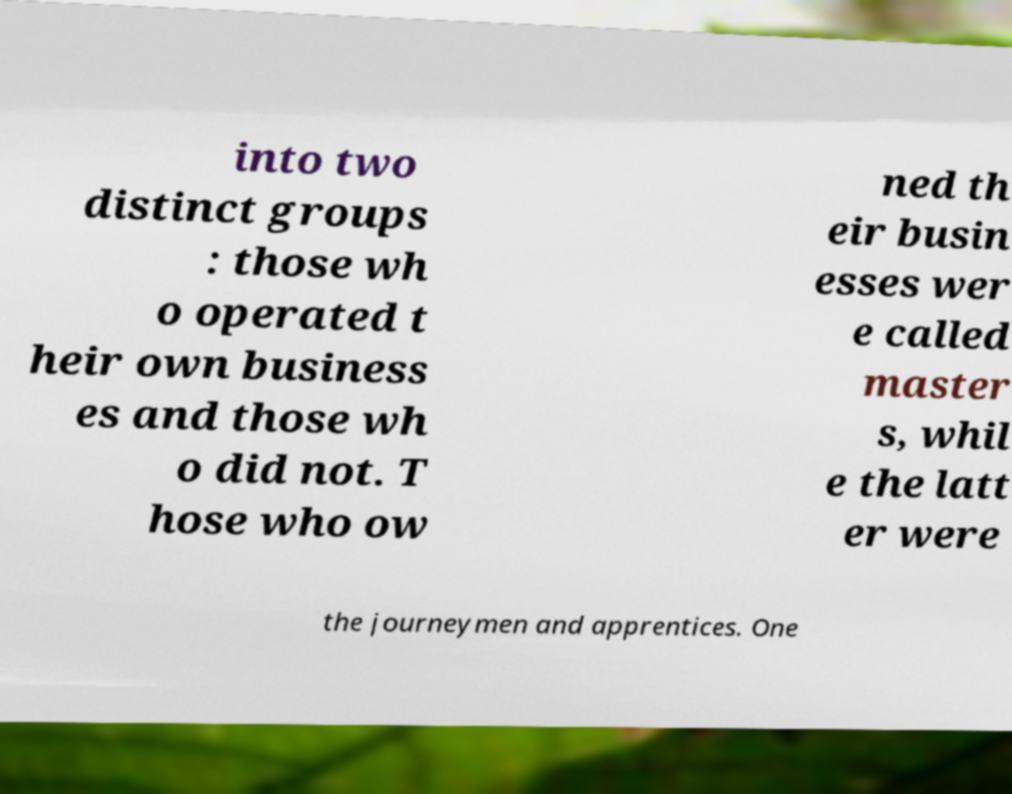For documentation purposes, I need the text within this image transcribed. Could you provide that? into two distinct groups : those wh o operated t heir own business es and those wh o did not. T hose who ow ned th eir busin esses wer e called master s, whil e the latt er were the journeymen and apprentices. One 